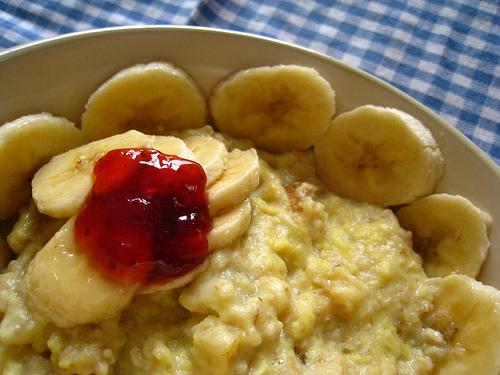Describe the table setting where the bowl of oatmeal is placed. The bowl of oatmeal is placed on a table with a blue and white checkered tablecloth, with creases or wrinkles in the tablecloth. In the multi-choice VQA task, what kind of pattern does the tablecloth have: striped, checkered, or floral? The tablecloth has a checkered pattern. In this image, identify the kind of fruit served with the oatmeal and describe its form. The fruit served with the oatmeal is bananas, which are cut into circular slices and arranged around the bowl. Please describe the primary food item in this image and how it is presented. The primary food item is oatmeal served in a white circular bowl with sliced bananas arranged around the perimeter and a topping of strawberry jam. In the referential expression grounding task, locate the element in the image that causes a visible disturbance in the tablecloth.  A crease or wrinkle in the tablecloth causes a visible disturbance. Mention the pattern and colors of the tablecloth underneath the bowl of oatmeal. The tablecloth has a blue and white checkered pattern. In the visual entailment task, can you infer that the oatmeal is served for breakfast? Yes, it can be inferred that the oatmeal is served for breakfast, as it is a common breakfast dish combined with fruit and jam for added flavor. For a product advertisement, describe the oatmeal bowl highlighting its features and toppings. Indulge in a delicious bowl of creamy oatmeal, carefully layered with perfectly sliced bananas and generously topped with a vibrant strawberry jam. Served in an elegant white, circular bowl - this oatmeal is the perfect way to kickstart your day! What is the topping on the bananas in the oatmeal, and what color does it appear to be? The topping on the bananas is strawberry jam, which appears to be a reddish-pinkish color. Explain how the oatmeal is arranged in the bowl, including any additions or garnishes. The oatmeal is arranged in the circular white bowl, surrounded by sliced bananas and topped with a generous glob of strawberry jam. 